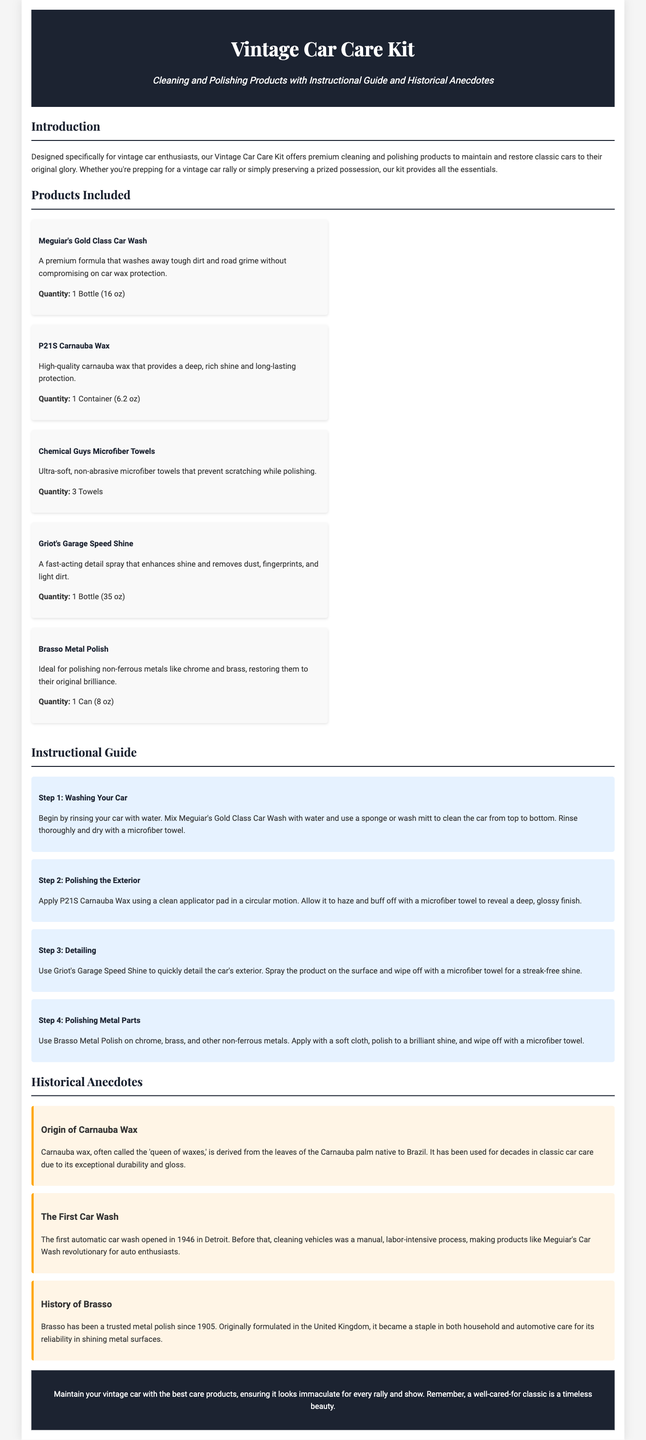what products are included in the Vintage Car Care Kit? The document lists several products under the "Products Included" section.
Answer: Meguiar's Gold Class Car Wash, P21S Carnauba Wax, Chemical Guys Microfiber Towels, Griot's Garage Speed Shine, Brasso Metal Polish how many microfiber towels are in the kit? The quantity of microfiber towels is specified in the product description.
Answer: 3 Towels what is the first step in the instructional guide? The first step of the instructional guide is mentioned in the "Instructional Guide" section.
Answer: Washing Your Car what is the quantity of P21S Carnauba Wax? The quantity of P21S Carnauba Wax is detailed in its description.
Answer: 1 Container (6.2 oz) what year did the first automatic car wash open? The year is mentioned in the historical anecdote regarding automatic car washes.
Answer: 1946 what is the origin of Carnauba wax? The origin of Carnauba wax is discussed in the historical anecdotes section.
Answer: Brazil how long has Brasso been a trusted metal polish? The document provides specific information about the history of Brasso in the historical anecdotes.
Answer: Since 1905 what type of metals does Brasso polish? The document specifies what types of metals Brasso is ideal for polishing.
Answer: Non-ferrous metals like chrome and brass 